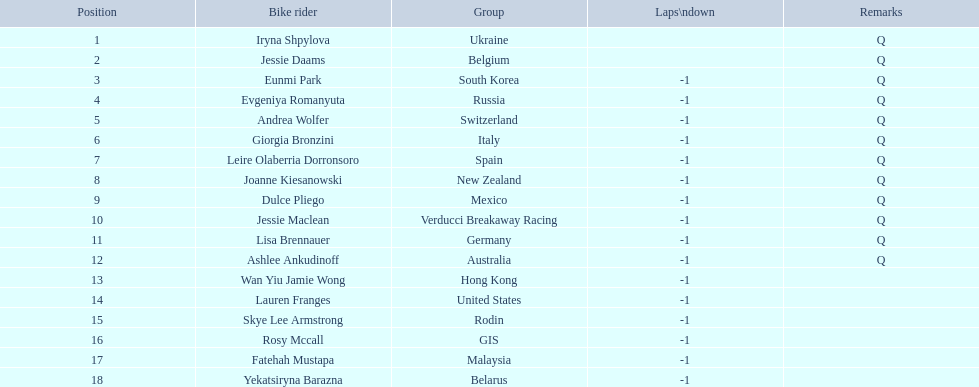Who are all the cyclists? Iryna Shpylova, Jessie Daams, Eunmi Park, Evgeniya Romanyuta, Andrea Wolfer, Giorgia Bronzini, Leire Olaberria Dorronsoro, Joanne Kiesanowski, Dulce Pliego, Jessie Maclean, Lisa Brennauer, Ashlee Ankudinoff, Wan Yiu Jamie Wong, Lauren Franges, Skye Lee Armstrong, Rosy Mccall, Fatehah Mustapa, Yekatsiryna Barazna. What were their ranks? 1, 2, 3, 4, 5, 6, 7, 8, 9, 10, 11, 12, 13, 14, 15, 16, 17, 18. Who was ranked highest? Iryna Shpylova. 